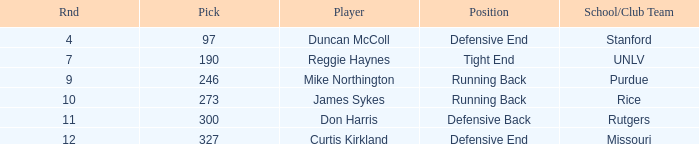What is the total number of rounds that had draft pick 97, duncan mccoll? 0.0. 